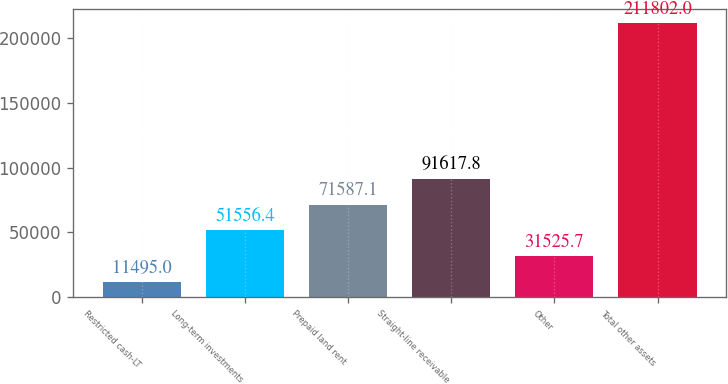Convert chart. <chart><loc_0><loc_0><loc_500><loc_500><bar_chart><fcel>Restricted cash-LT<fcel>Long-term investments<fcel>Prepaid land rent<fcel>Straight-line receivable<fcel>Other<fcel>Total other assets<nl><fcel>11495<fcel>51556.4<fcel>71587.1<fcel>91617.8<fcel>31525.7<fcel>211802<nl></chart> 